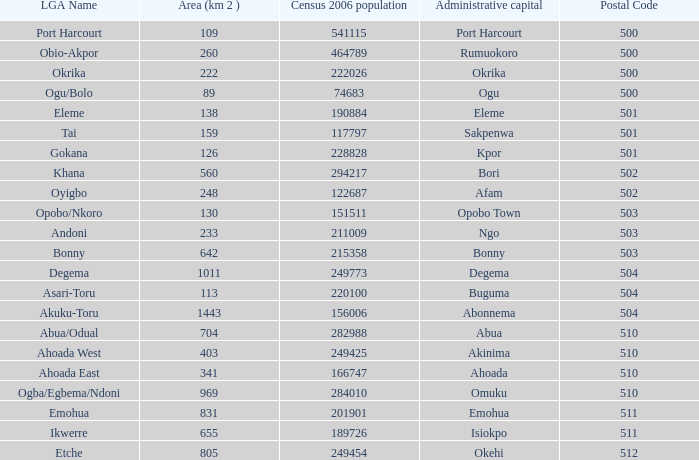What is the zip code when the administrative headquarters is in bori? 502.0. 